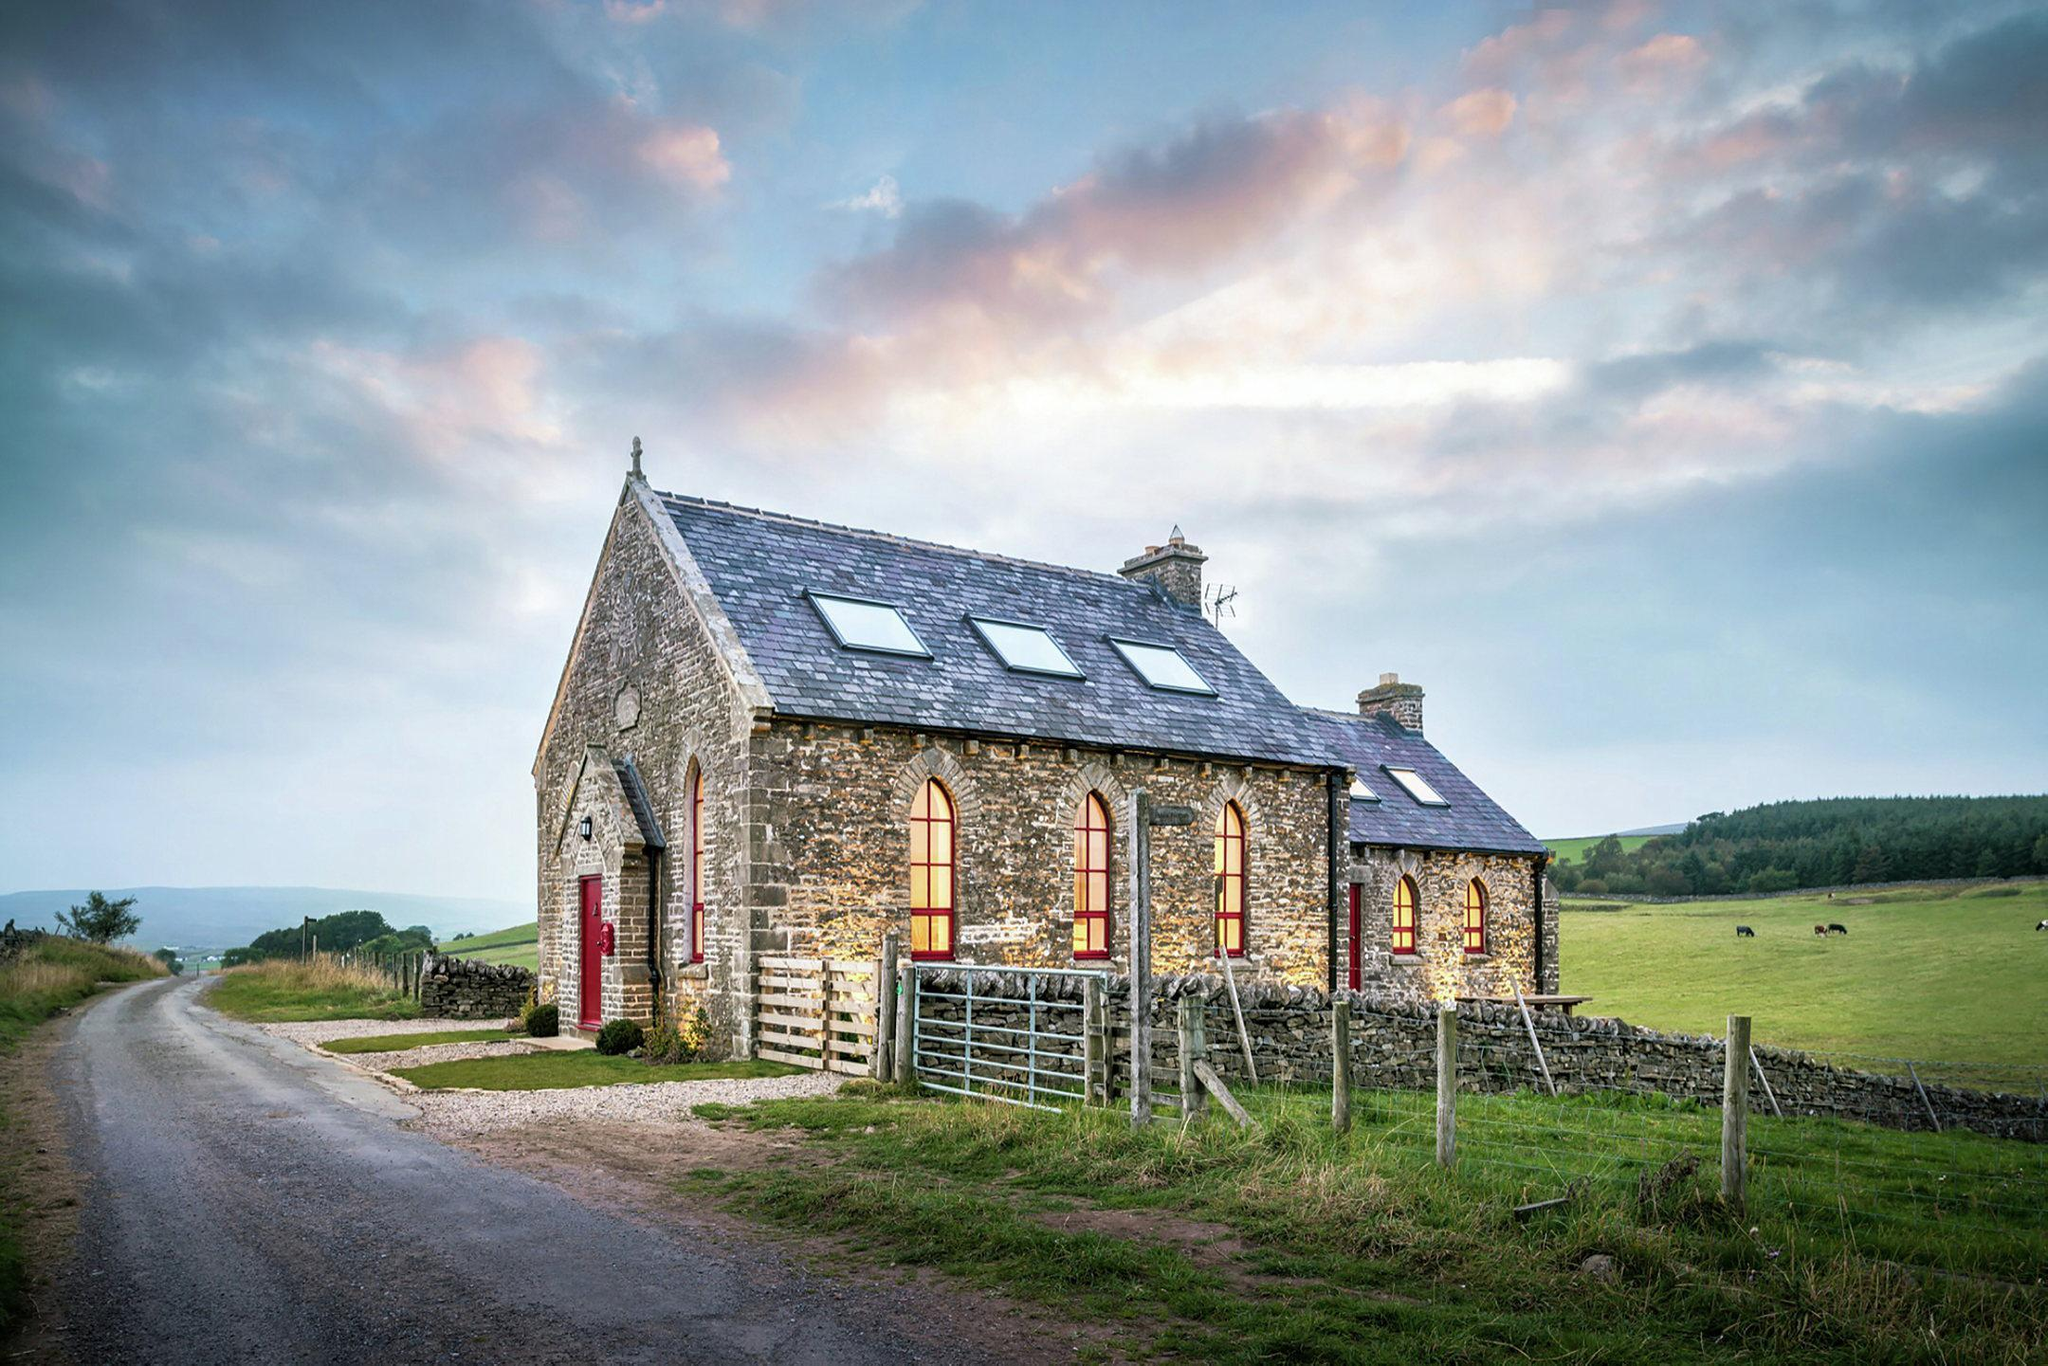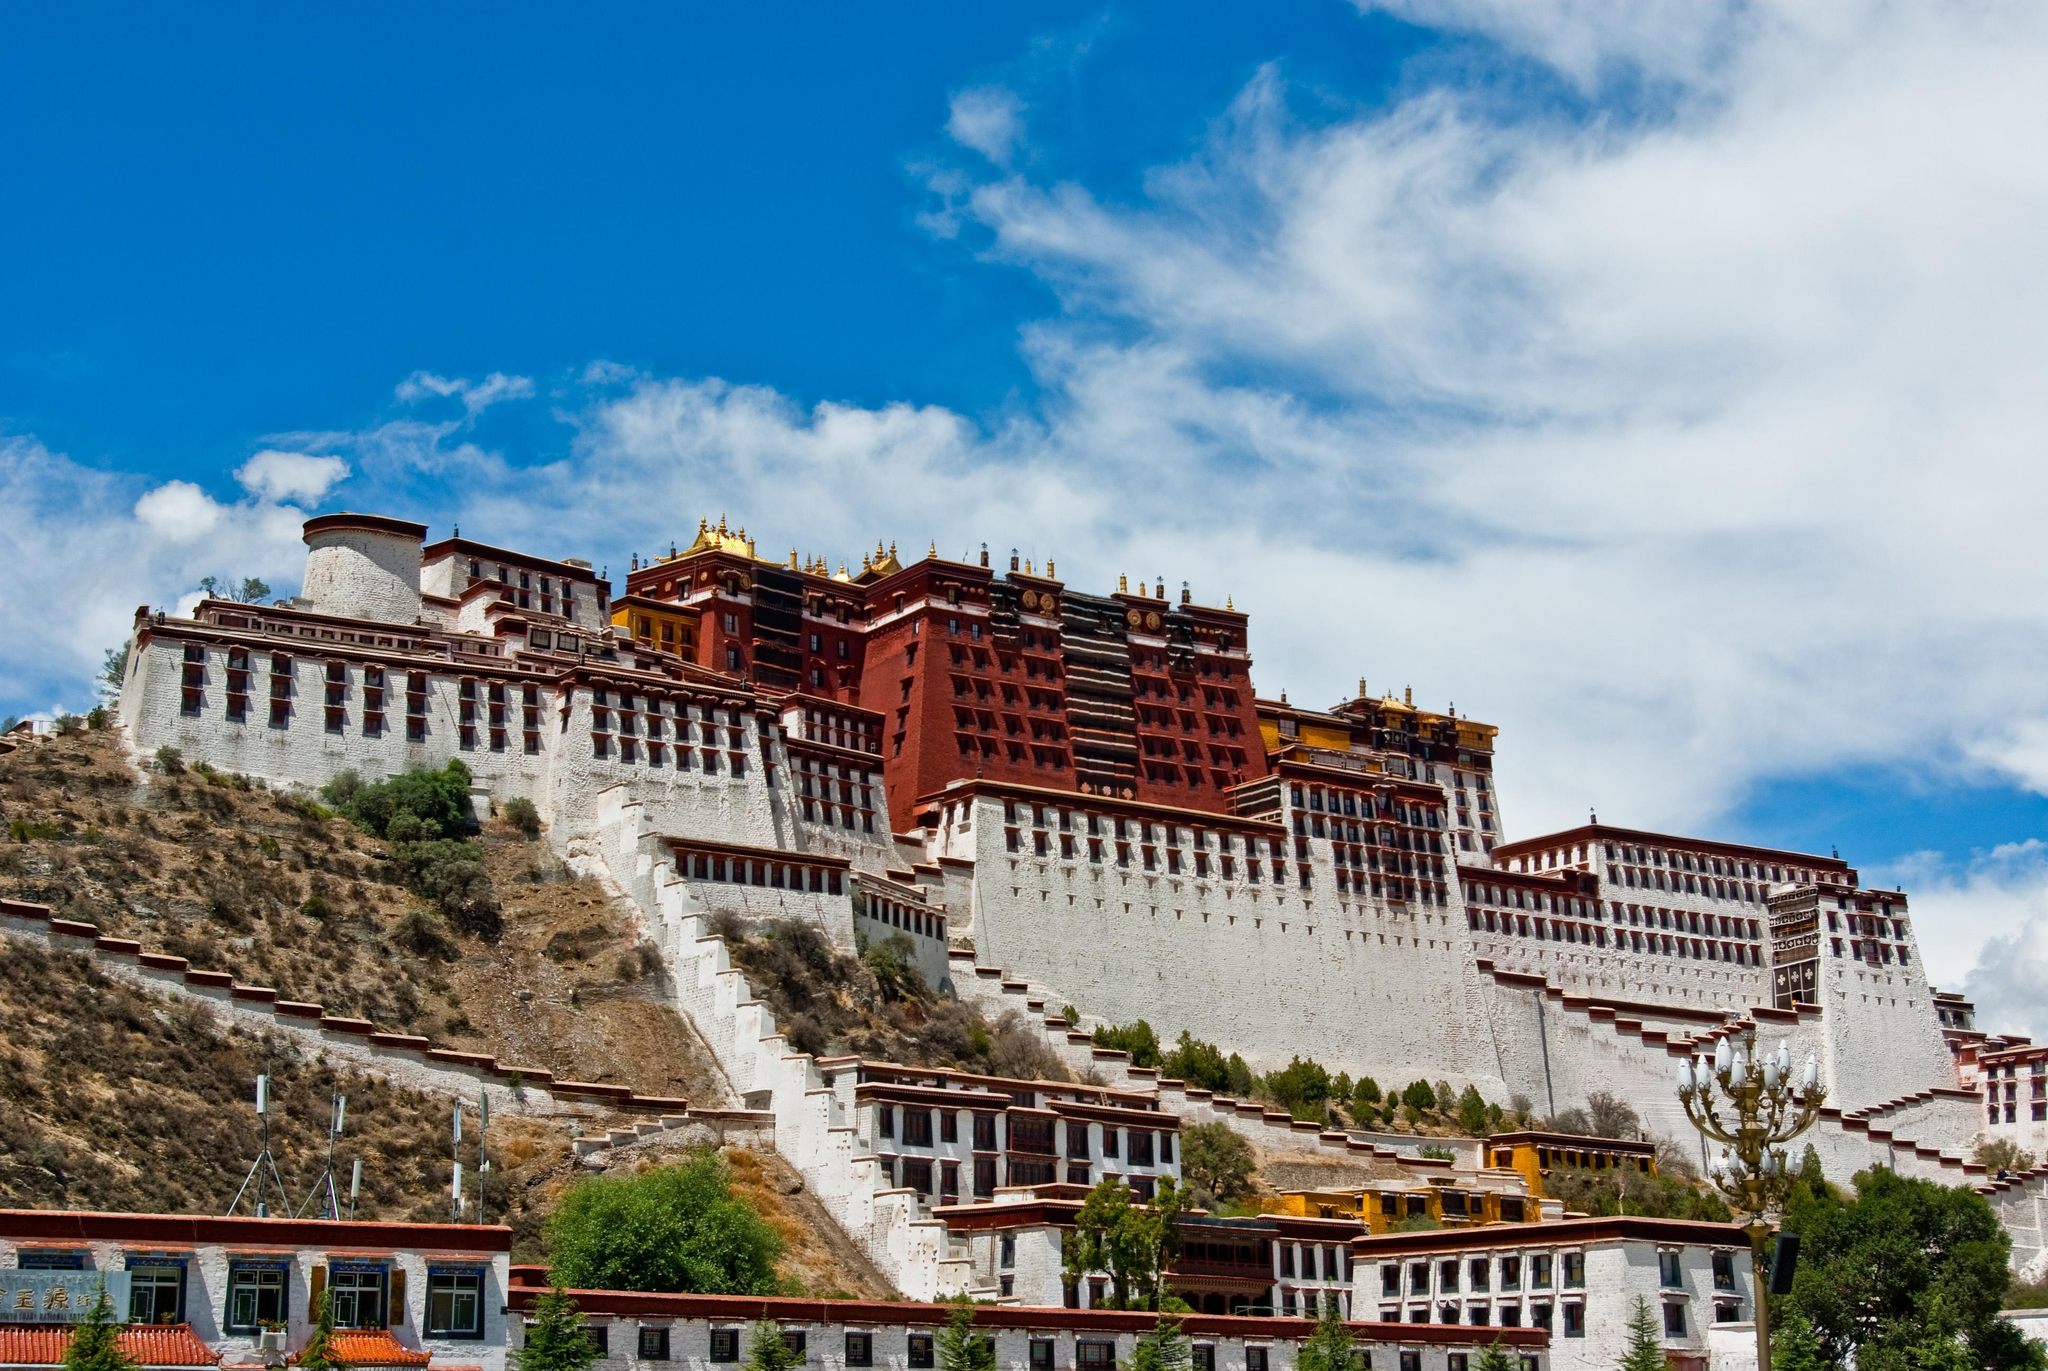The first image is the image on the left, the second image is the image on the right. Analyze the images presented: Is the assertion "There is a cozy white house on a level ground with trees behind it." valid? Answer yes or no. No. 